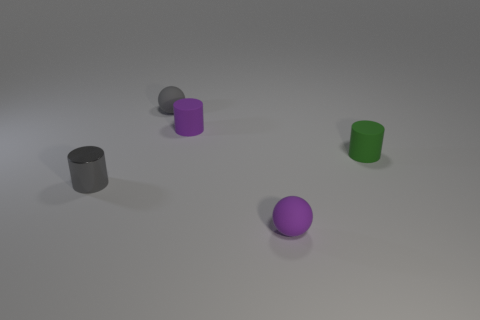There is a gray cylinder that is the same size as the purple cylinder; what is it made of?
Give a very brief answer. Metal. What size is the gray rubber ball that is on the left side of the tiny purple matte object behind the tiny matte sphere right of the gray rubber sphere?
Ensure brevity in your answer.  Small. How many other objects are the same material as the tiny green object?
Ensure brevity in your answer.  3. What number of objects are left of the tiny green thing and behind the purple sphere?
Your response must be concise. 3. There is a tiny ball in front of the object that is on the right side of the small purple sphere; what is its material?
Provide a succinct answer. Rubber. There is a purple thing that is the same shape as the small green rubber thing; what is its material?
Offer a terse response. Rubber. Are there any balls?
Ensure brevity in your answer.  Yes. The tiny purple object that is the same material as the small purple ball is what shape?
Provide a short and direct response. Cylinder. There is a gray cylinder behind the purple ball; what is its material?
Offer a very short reply. Metal. Does the thing that is in front of the tiny metal object have the same color as the shiny object?
Your response must be concise. No. 